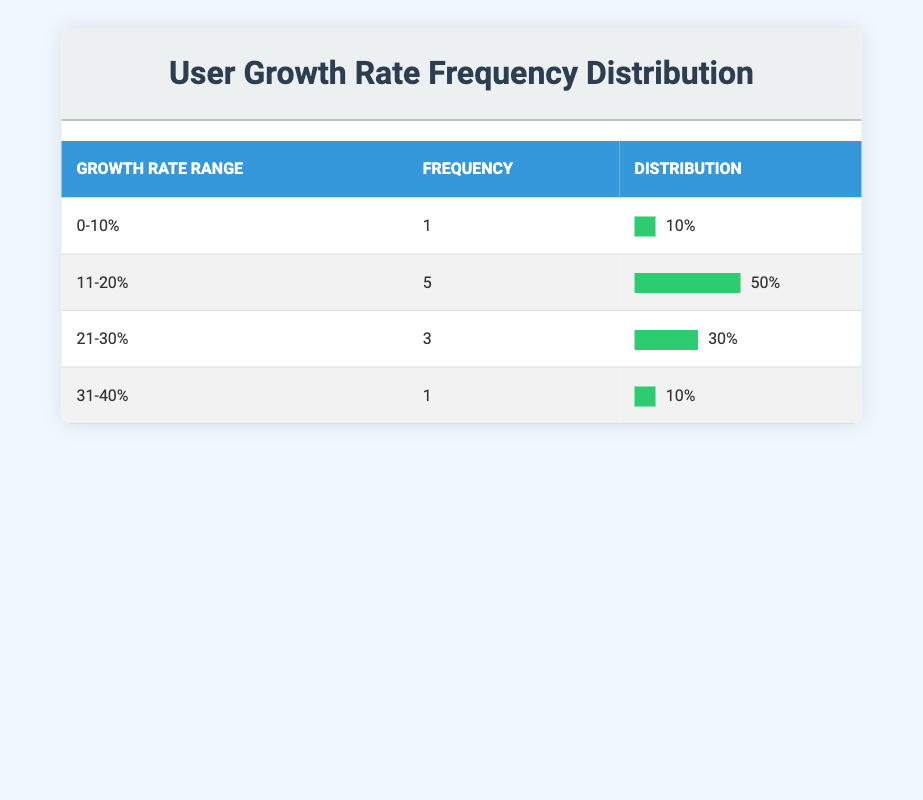What is the frequency of closed-source software companies with a user growth rate of 0-10%? The table shows that there is 1 company listed in the growth rate range of 0-10%.
Answer: 1 How many companies have a user growth rate between 11-20%? By looking at the table, there are 5 companies that fall within the 11-20% growth rate range.
Answer: 5 Which growth rate range has the highest frequency of companies? The 11-20% growth rate range has the highest frequency with 5 companies, compared to other ranges.
Answer: 11-20% What is the average user growth rate for companies in the 21-30% range? There are 3 companies in this range: Atlassian (30%), and no others; thus the average is (30) / 1 = 30.
Answer: 30 Is there a company with a user growth rate of more than 30%? Yes, Zoom Video Communications and Atlassian both have growth rates above 30% (40% and 30%, respectively).
Answer: Yes How many companies have a user growth rate of 31-40%? The table indicates that 1 company, Zoom Video Communications, falls within the 31-40% range.
Answer: 1 What percentage of companies have a user growth rate of 20% or less? Adding the frequencies for the 0-10% (1) and the 11-20% (5) ranges gives a total of 6 companies. The total number of companies is 10, so (6/10)*100 = 60%.
Answer: 60% If we consider the user growth rates of all companies, what is the total number of companies exceeding 20% growth? The ranges over 20% are 21-30% (3 companies) and 31-40% (1 company), resulting in 4 companies exceeding 20% growth.
Answer: 4 In terms of frequency, how does the range 31-40% compare to the 11-20% range? The 11-20% range has 5 companies, while the 31-40% range has only 1, meaning that 11-20% exceeds 31-40% significantly.
Answer: 11-20% is greater 